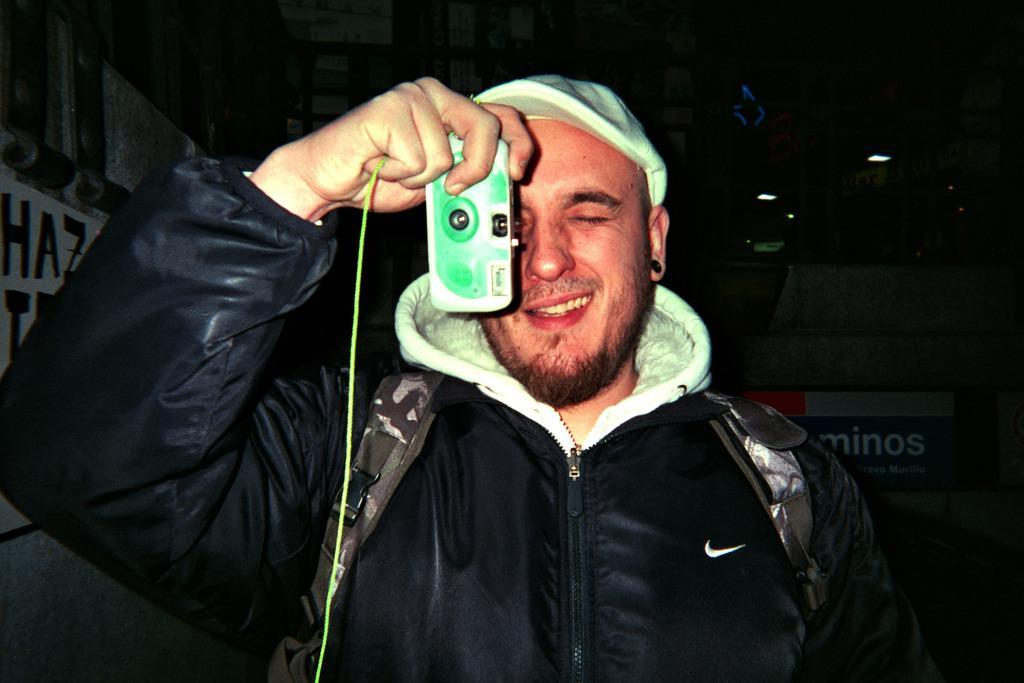Can you describe this image briefly? In this picture we can see a man smiling, holding a camera with his hand and at the back of him we can see the lights, posters, some objects and in the background it is dark. 